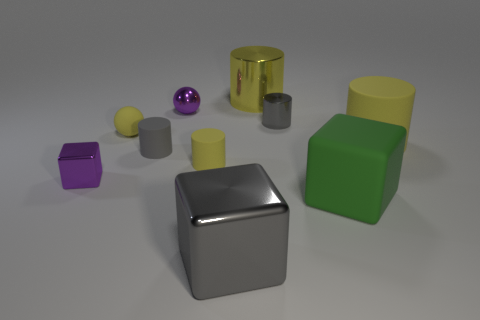Subtract all yellow cylinders. How many were subtracted if there are1yellow cylinders left? 2 Subtract all yellow shiny cylinders. How many cylinders are left? 4 Subtract 2 cubes. How many cubes are left? 1 Add 3 purple blocks. How many purple blocks exist? 4 Subtract all yellow balls. How many balls are left? 1 Subtract 2 gray cylinders. How many objects are left? 8 Subtract all balls. How many objects are left? 8 Subtract all gray blocks. Subtract all yellow balls. How many blocks are left? 2 Subtract all cyan blocks. How many gray cylinders are left? 2 Subtract all green matte blocks. Subtract all matte things. How many objects are left? 4 